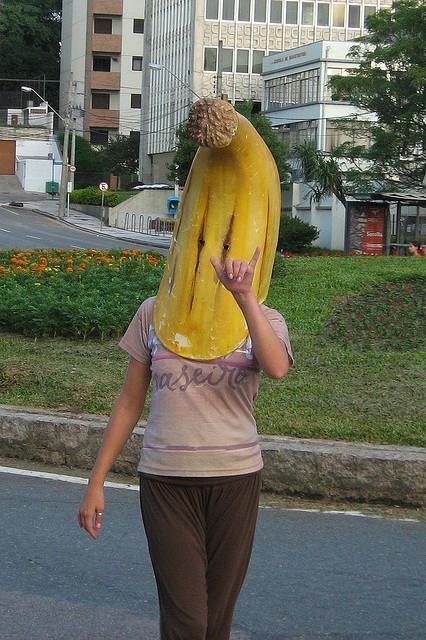How many keyboards are there?
Give a very brief answer. 0. 